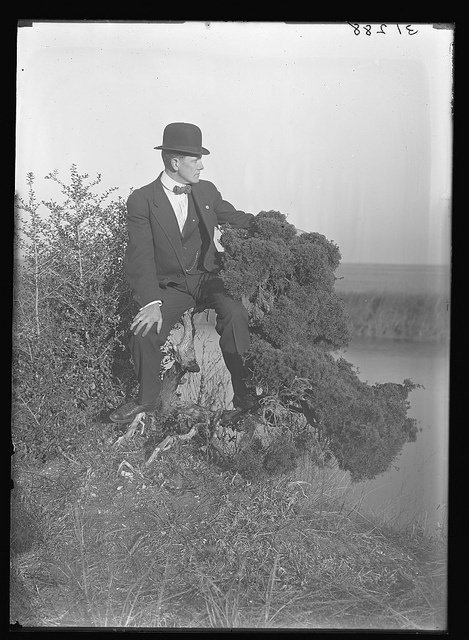Describe the objects in this image and their specific colors. I can see people in black, gray, darkgray, and lightgray tones and tie in gray, darkgray, silver, and black tones in this image. 